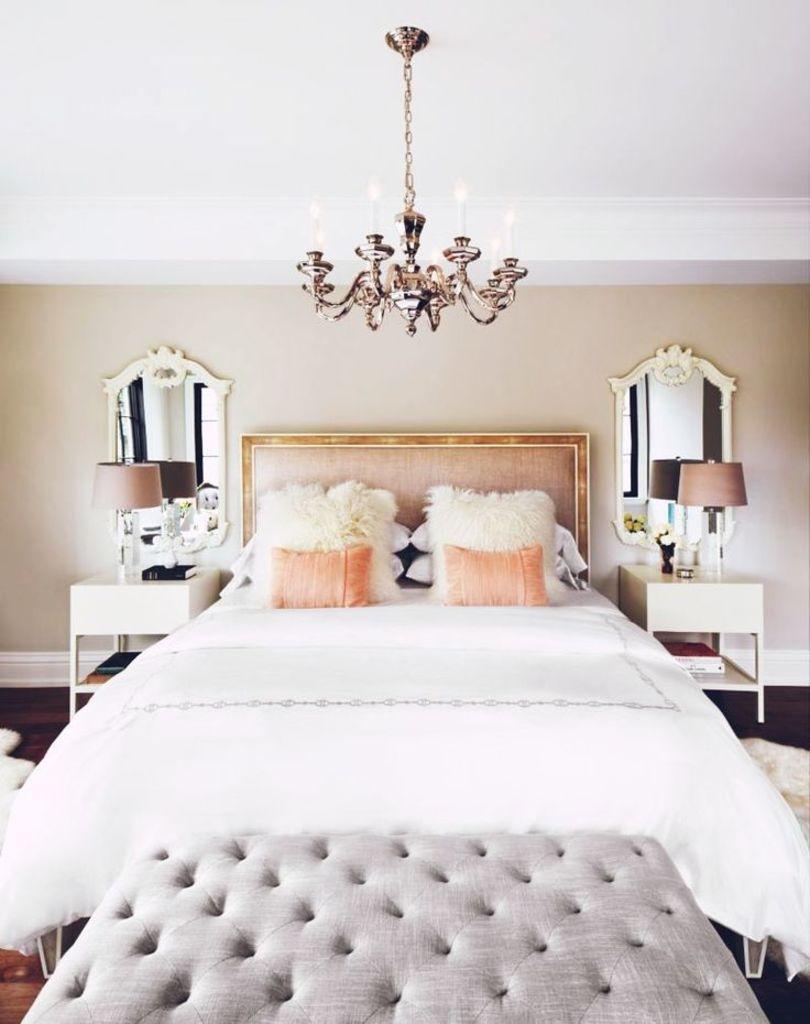How would you summarize this image in a sentence or two? In this image I can see the pillows on the bed. On both sides of the bed I can see the tables. On the tables I can see the lamps and few objects. In the background I can see the mirrors to the wall and there is a candle chandelier at the top. In-front of the bed I can see an ash color object. 